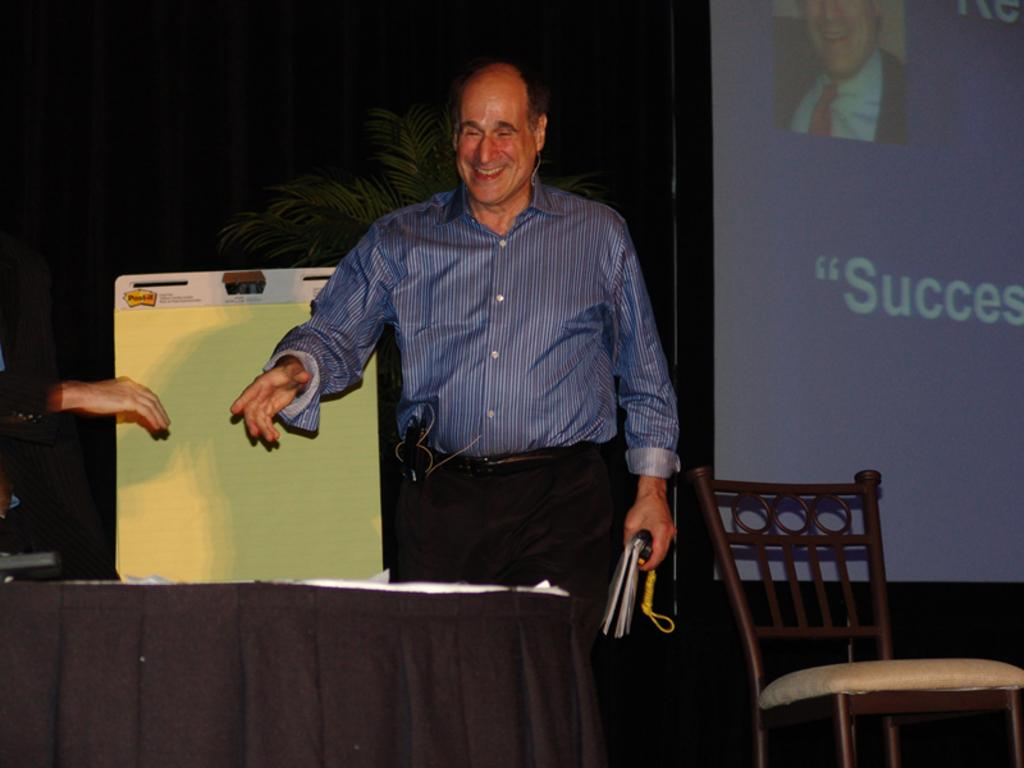What is the person in the image doing? The person is standing and smiling. What can be seen in front of the person? There is a black table in front of the person. What is visible behind the person? There is a projected image behind the person. What type of fly is sitting on the person's son's shoulder in the image? There is no son or fly present in the image. 